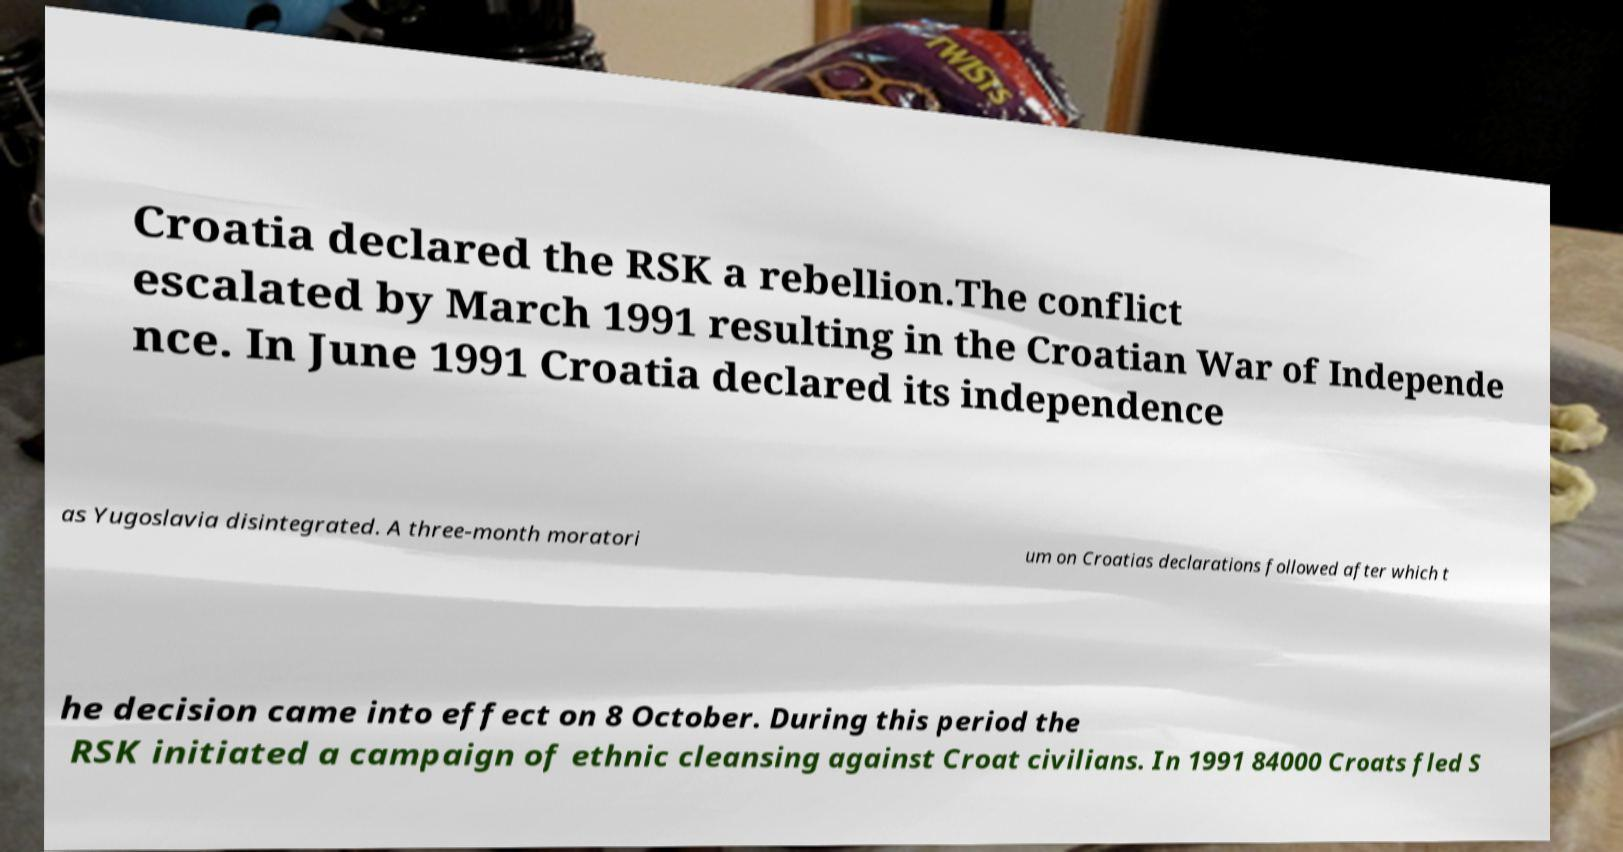I need the written content from this picture converted into text. Can you do that? Croatia declared the RSK a rebellion.The conflict escalated by March 1991 resulting in the Croatian War of Independe nce. In June 1991 Croatia declared its independence as Yugoslavia disintegrated. A three-month moratori um on Croatias declarations followed after which t he decision came into effect on 8 October. During this period the RSK initiated a campaign of ethnic cleansing against Croat civilians. In 1991 84000 Croats fled S 